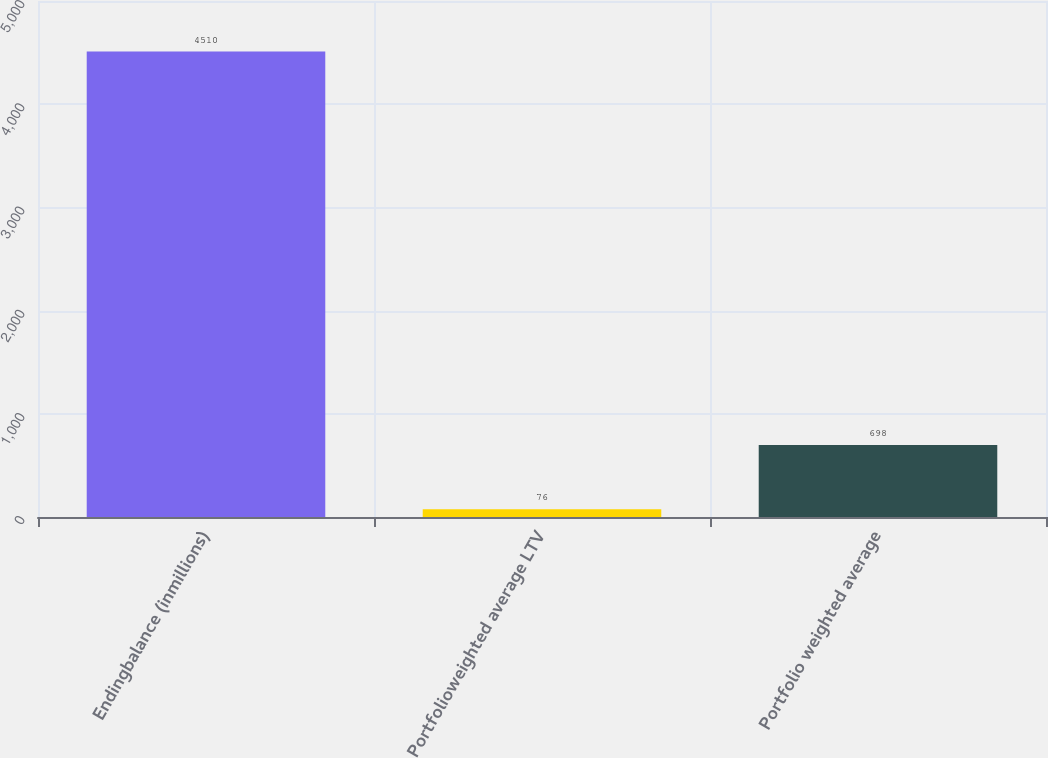Convert chart to OTSL. <chart><loc_0><loc_0><loc_500><loc_500><bar_chart><fcel>Endingbalance (inmillions)<fcel>Portfolioweighted average LTV<fcel>Portfolio weighted average<nl><fcel>4510<fcel>76<fcel>698<nl></chart> 